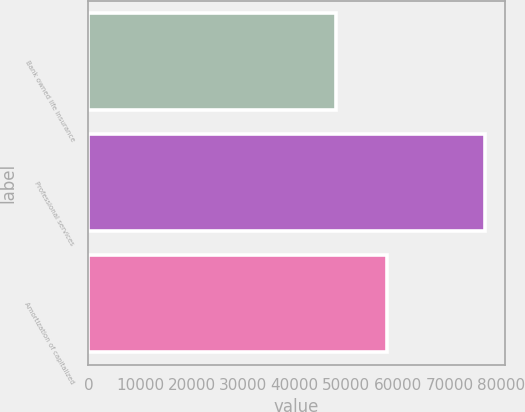<chart> <loc_0><loc_0><loc_500><loc_500><bar_chart><fcel>Bank owned life insurance<fcel>Professional services<fcel>Amortization of capitalized<nl><fcel>48010<fcel>76868<fcel>57885<nl></chart> 